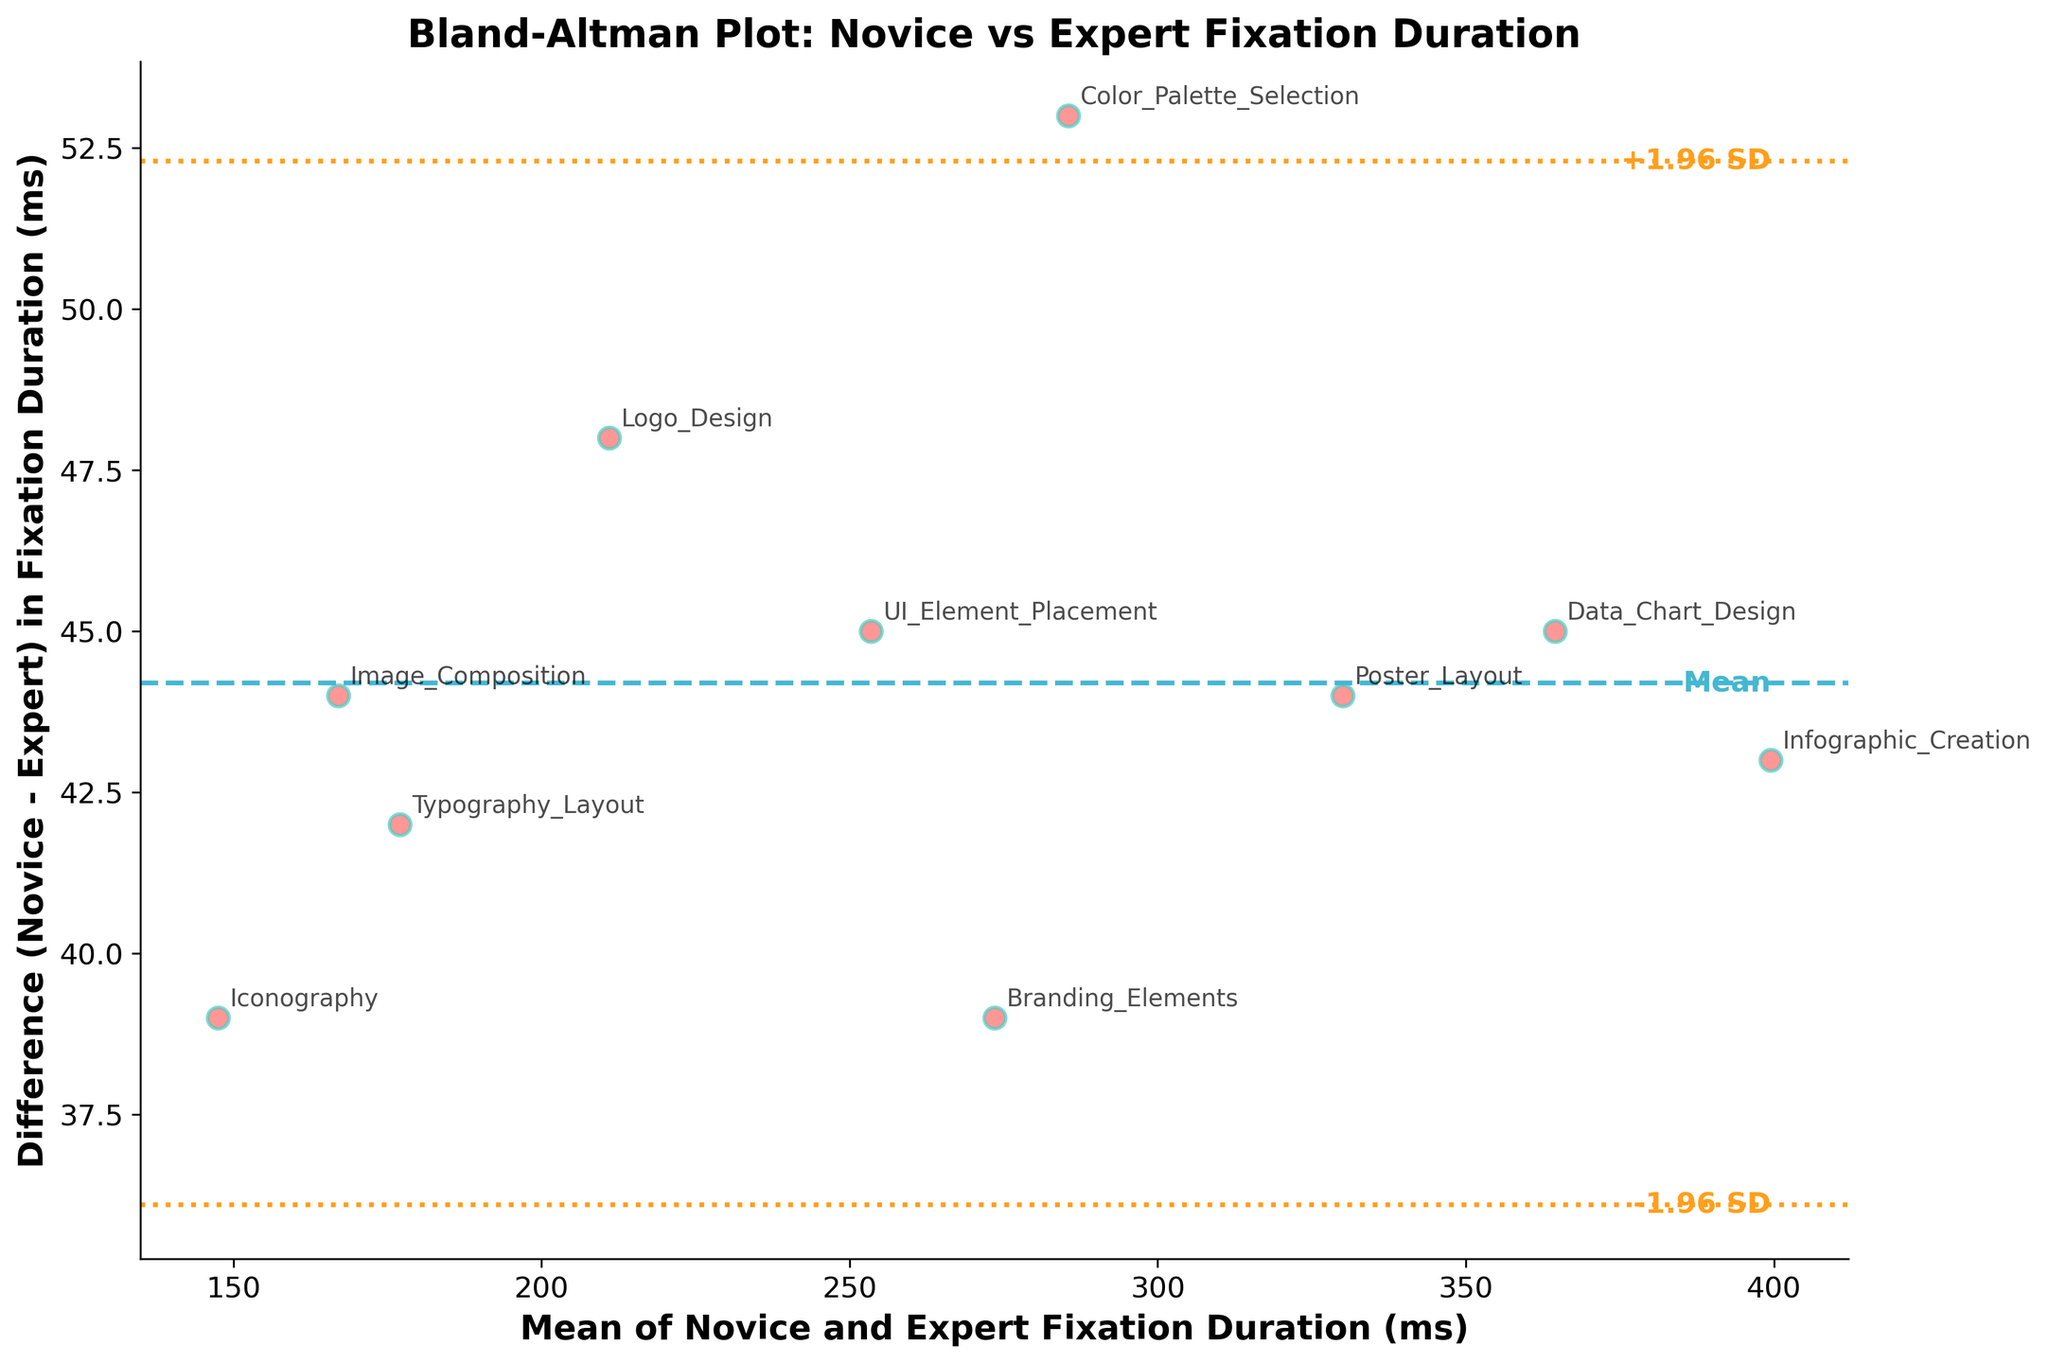How many data points are shown in the Bland-Altman plot? Count the number of scatter points in the graph. Each point represents a subject's fixation duration for both novice and expert designers.
Answer: 10 What is the title of the plot? Read the title written at the top of the plot.
Answer: Bland-Altman Plot: Novice vs Expert Fixation Duration Which subject has the largest fixation duration for novices? Identify the scatter point that represents the maximum up for novice fixation duration from the data labels annotated near each point.
Answer: Infographic_Creation What are the limits of agreement? Locate the two dashed horizontal lines that represent the limits of agreement (-1.96 SD and +1.96 SD), usually labeled in the graph.
Answer: approximately -7.1 ms and 93.7 ms Which subject has the smallest difference in fixation duration between novices and experts? Identify the scatter point closest to the mean difference line labeled 'Mean'. The label near this point will give the subject.
Answer: Iconography For which subject is the mean fixation duration higher: Poster_Layout or Color_Palette_Selection? Calculate the mean fixation duration for both subjects using their data points, then compare them. Poster_Layout: (352+308)/2 = 330 ms; Color_Palette_Selection: (312+259)/2 = 285.5 ms.
Answer: Poster_Layout What does a data point above the mean difference line indicate? A data point above the mean difference line indicates that the novice fixation duration is greater than the expert fixation duration by a certain difference.
Answer: Novice > Expert Are there any subjects with a negative difference in fixation duration? Check if any data points are below the mean difference line. The presence of these points indicates a negative difference.
Answer: Yes Which subject has the highest mean fixation duration? Calculate the mean fixation duration for all subjects and identify the maximum. Infographic_Creation: (421+378)/2 = 399.5 ms.
Answer: Infographic_Creation 